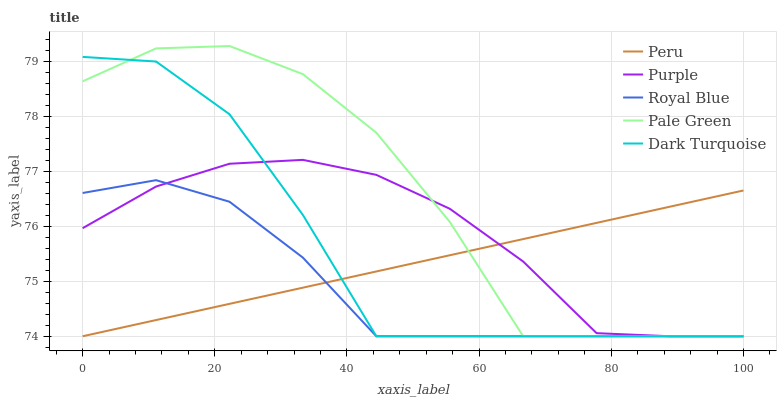Does Royal Blue have the minimum area under the curve?
Answer yes or no. Yes. Does Pale Green have the maximum area under the curve?
Answer yes or no. Yes. Does Pale Green have the minimum area under the curve?
Answer yes or no. No. Does Royal Blue have the maximum area under the curve?
Answer yes or no. No. Is Peru the smoothest?
Answer yes or no. Yes. Is Pale Green the roughest?
Answer yes or no. Yes. Is Royal Blue the smoothest?
Answer yes or no. No. Is Royal Blue the roughest?
Answer yes or no. No. Does Purple have the lowest value?
Answer yes or no. Yes. Does Pale Green have the highest value?
Answer yes or no. Yes. Does Royal Blue have the highest value?
Answer yes or no. No. Does Peru intersect Royal Blue?
Answer yes or no. Yes. Is Peru less than Royal Blue?
Answer yes or no. No. Is Peru greater than Royal Blue?
Answer yes or no. No. 